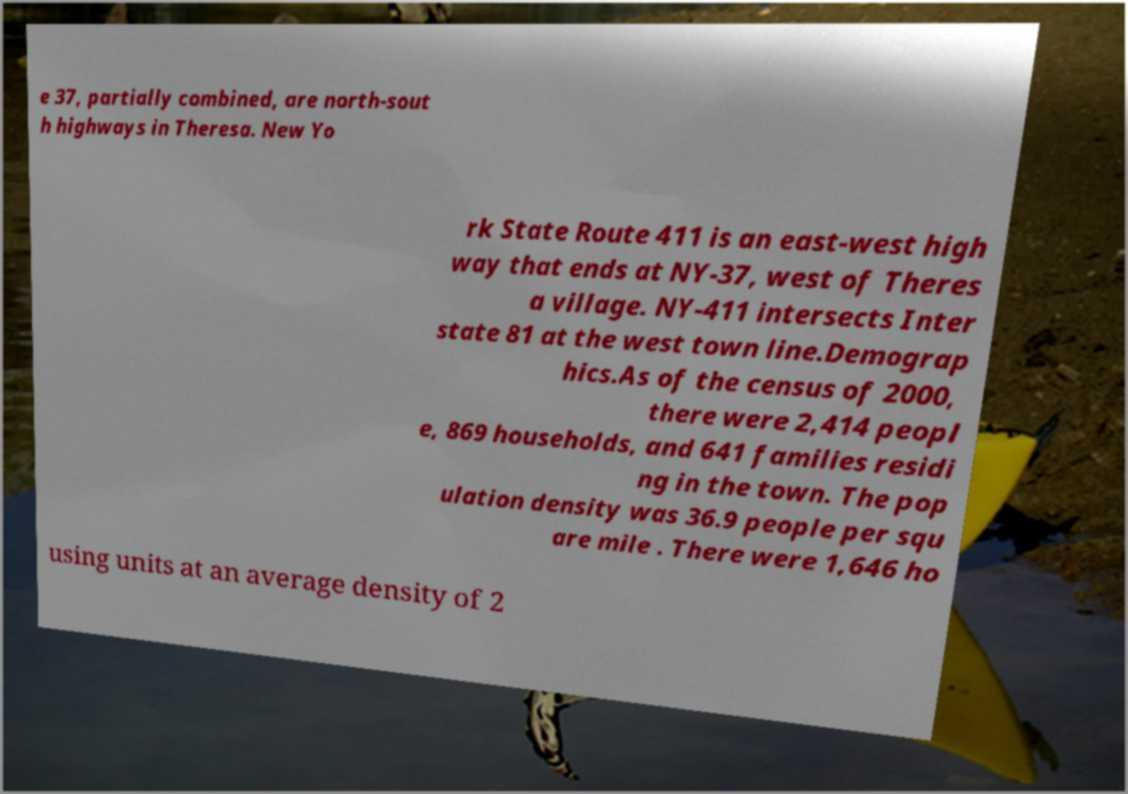For documentation purposes, I need the text within this image transcribed. Could you provide that? e 37, partially combined, are north-sout h highways in Theresa. New Yo rk State Route 411 is an east-west high way that ends at NY-37, west of Theres a village. NY-411 intersects Inter state 81 at the west town line.Demograp hics.As of the census of 2000, there were 2,414 peopl e, 869 households, and 641 families residi ng in the town. The pop ulation density was 36.9 people per squ are mile . There were 1,646 ho using units at an average density of 2 